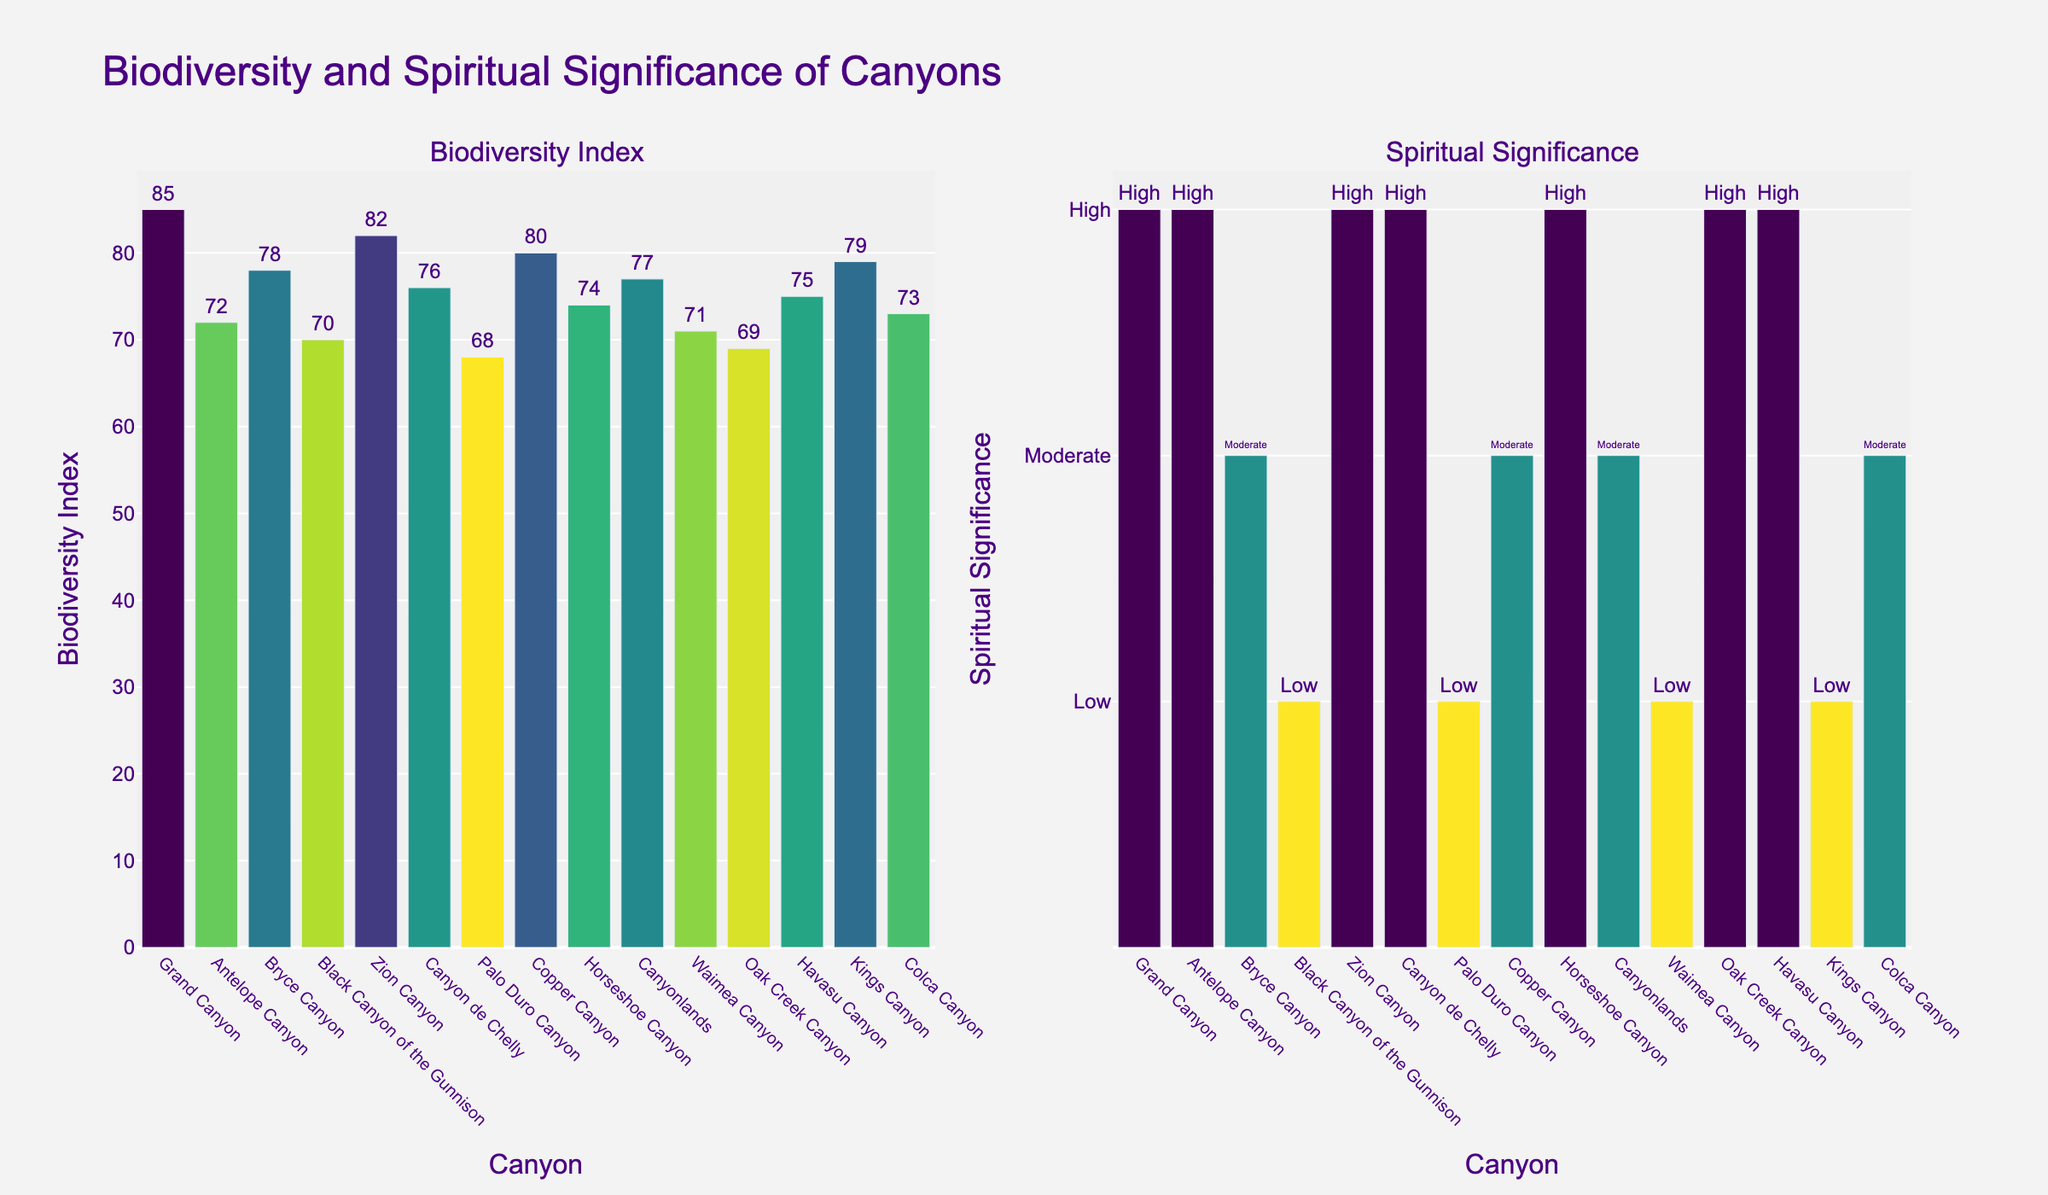Which canyon has the highest Biodiversity Index? The bar chart on the left side shows that Grand Canyon has the tallest bar in terms of Biodiversity Index.
Answer: Grand Canyon Which canyon has the lowest Spiritual Significance? The bar chart on the right side shows multiple canyons with the lowest bar, colored for low significance. These include Black Canyon of the Gunnison, Palo Duro Canyon, Waimea Canyon, and Kings Canyon.
Answer: Black Canyon of the Gunnison, Palo Duro Canyon, Waimea Canyon, Kings Canyon What is the Biodiversity Index of Havasu Canyon? The bar chart on the left side displays the height of the bar for Havasu Canyon, which indicates the Biodiversity Index value.
Answer: 75 How does the Biodiversity Index of Antelope Canyon compare to that of Oak Creek Canyon? The left bar chart shows that Antelope Canyon's bar is higher than Oak Creek Canyon's bar, indicating that Antelope Canyon has a higher Biodiversity Index.
Answer: Antelope Canyon has a higher Biodiversity Index What's the average Biodiversity Index of the canyons with high Spiritual Significance? The canyons with high Spiritual Significance are Grand Canyon (85), Antelope Canyon (72), Zion Canyon (82), Canyon de Chelly (76), Horseshoe Canyon (74), Oak Creek Canyon (69), and Havasu Canyon (75). The average is calculated as (85 + 72 + 82 + 76 + 74 + 69 + 75) / 7 = 533 / 7 ≈ 76.14.
Answer: 76.14 Which canyons show a Biodiversity Index of 80? The left bar chart indicates that Copper Canyon has a Biodiversity Index of 80.
Answer: Copper Canyon What is the difference in Biodiversity Index between Grand Canyon and Waimea Canyon? Grand Canyon has a Biodiversity Index of 85 and Waimea Canyon has a Biodiversity Index of 71. The difference is 85 - 71 = 14.
Answer: 14 Are there any canyons with both high Biodiversity Index and high Spiritual Significance? The left bar chart indicates high Biodiversity Index, and the right bar chart shows high Spiritual Significance. The comparison reveals that Grand Canyon, Zion Canyon, and Havasu Canyon meet both criteria.
Answer: Grand Canyon, Zion Canyon, Havasu Canyon Which canyon has the highest difference between Biodiversity Index and Spiritual Significance? Visual inspection of the two bar charts reveals that the greatest variation occurs in Antelope Canyon, where the Biodiversity Index is 72 (high on the left chart) and the Spiritual Significance is high on the right chart. This is a significant drop compared to others.
Answer: Antelope Canyon 